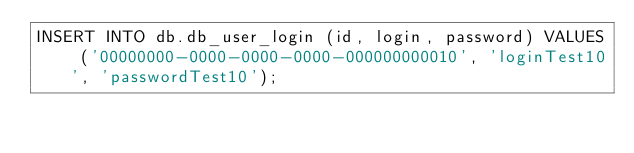<code> <loc_0><loc_0><loc_500><loc_500><_SQL_>INSERT INTO db.db_user_login (id, login, password) VALUES ('00000000-0000-0000-0000-000000000010', 'loginTest10', 'passwordTest10');
</code> 